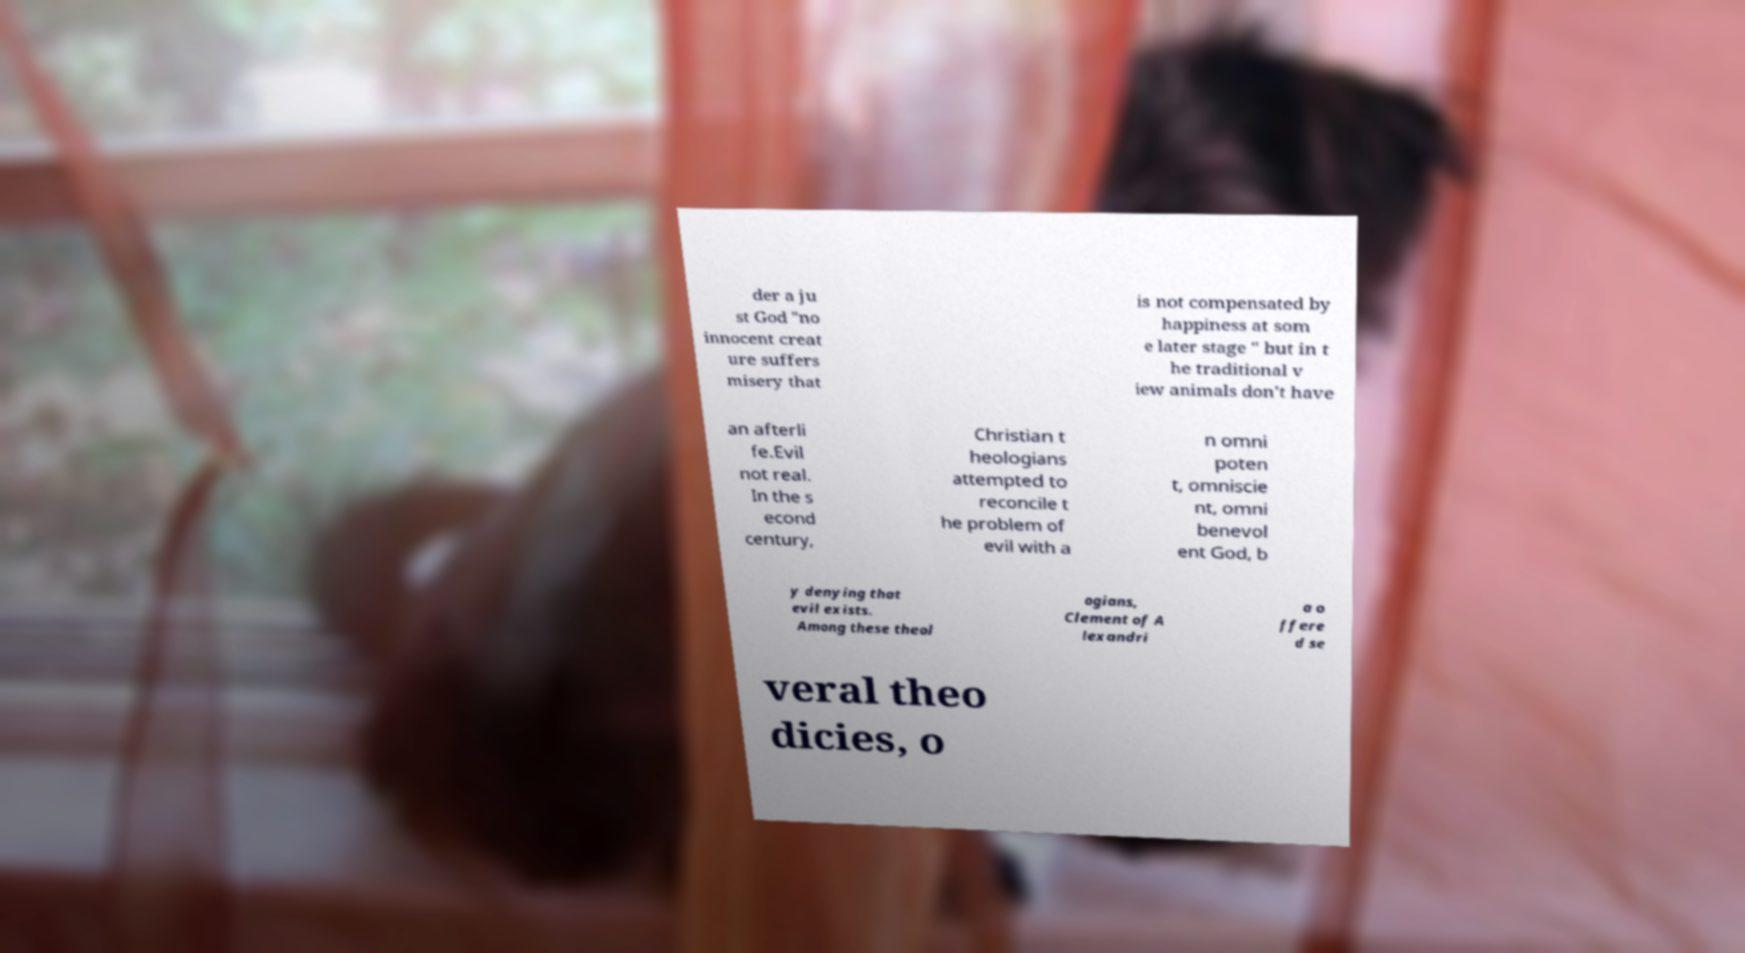Please identify and transcribe the text found in this image. der a ju st God "no innocent creat ure suffers misery that is not compensated by happiness at som e later stage " but in t he traditional v iew animals don't have an afterli fe.Evil not real. In the s econd century, Christian t heologians attempted to reconcile t he problem of evil with a n omni poten t, omniscie nt, omni benevol ent God, b y denying that evil exists. Among these theol ogians, Clement of A lexandri a o ffere d se veral theo dicies, o 